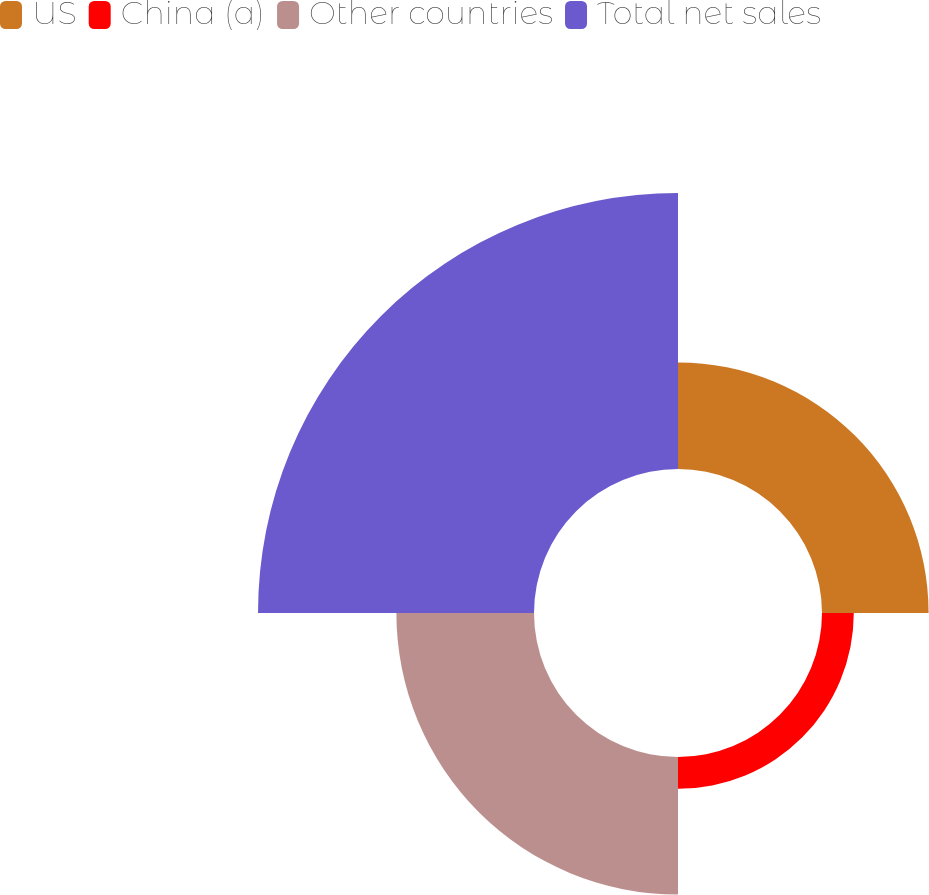Convert chart. <chart><loc_0><loc_0><loc_500><loc_500><pie_chart><fcel>US<fcel>China (a)<fcel>Other countries<fcel>Total net sales<nl><fcel>19.31%<fcel>5.76%<fcel>24.93%<fcel>50.0%<nl></chart> 